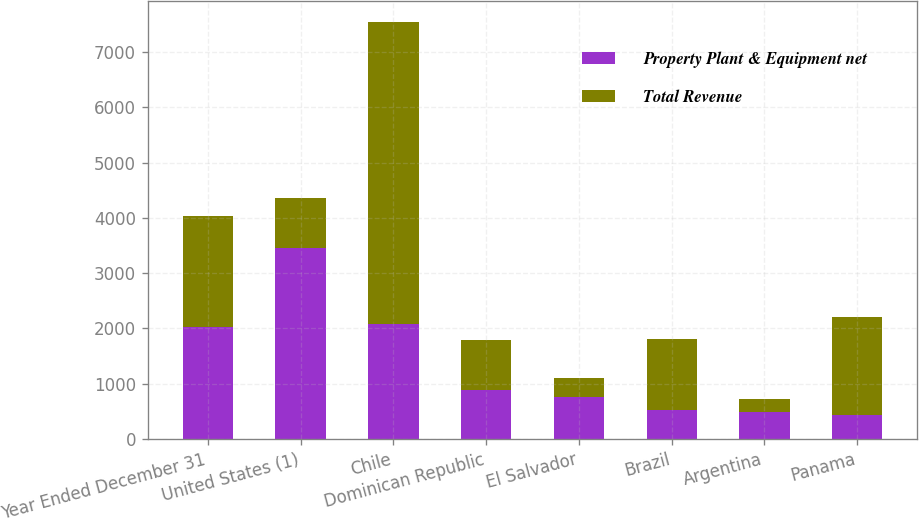Convert chart. <chart><loc_0><loc_0><loc_500><loc_500><stacked_bar_chart><ecel><fcel>Year Ended December 31<fcel>United States (1)<fcel>Chile<fcel>Dominican Republic<fcel>El Salvador<fcel>Brazil<fcel>Argentina<fcel>Panama<nl><fcel>Property Plant & Equipment net<fcel>2018<fcel>3462<fcel>2087<fcel>884<fcel>768<fcel>527<fcel>487<fcel>438<nl><fcel>Total Revenue<fcel>2018<fcel>903<fcel>5453<fcel>903<fcel>334<fcel>1287<fcel>234<fcel>1777<nl></chart> 